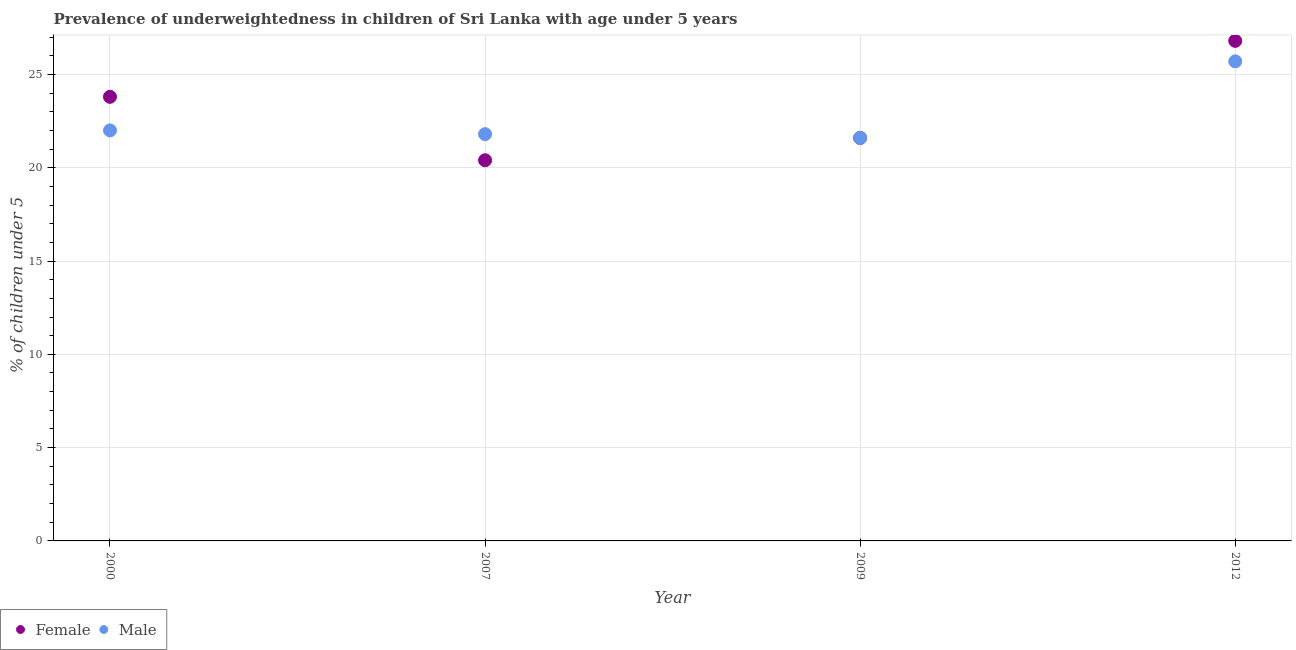Is the number of dotlines equal to the number of legend labels?
Make the answer very short. Yes. What is the percentage of underweighted female children in 2009?
Provide a succinct answer. 21.6. Across all years, what is the maximum percentage of underweighted female children?
Give a very brief answer. 26.8. Across all years, what is the minimum percentage of underweighted male children?
Keep it short and to the point. 21.6. In which year was the percentage of underweighted female children maximum?
Offer a terse response. 2012. In which year was the percentage of underweighted male children minimum?
Provide a short and direct response. 2009. What is the total percentage of underweighted male children in the graph?
Your answer should be very brief. 91.1. What is the difference between the percentage of underweighted male children in 2000 and that in 2009?
Ensure brevity in your answer.  0.4. What is the difference between the percentage of underweighted female children in 2012 and the percentage of underweighted male children in 2009?
Make the answer very short. 5.2. What is the average percentage of underweighted male children per year?
Ensure brevity in your answer.  22.78. In the year 2007, what is the difference between the percentage of underweighted male children and percentage of underweighted female children?
Ensure brevity in your answer.  1.4. In how many years, is the percentage of underweighted female children greater than 16 %?
Ensure brevity in your answer.  4. What is the ratio of the percentage of underweighted female children in 2000 to that in 2012?
Offer a very short reply. 0.89. Is the percentage of underweighted male children in 2000 less than that in 2007?
Your response must be concise. No. Is the difference between the percentage of underweighted male children in 2000 and 2009 greater than the difference between the percentage of underweighted female children in 2000 and 2009?
Your answer should be very brief. No. What is the difference between the highest and the second highest percentage of underweighted male children?
Keep it short and to the point. 3.7. What is the difference between the highest and the lowest percentage of underweighted male children?
Offer a terse response. 4.1. In how many years, is the percentage of underweighted male children greater than the average percentage of underweighted male children taken over all years?
Give a very brief answer. 1. Is the sum of the percentage of underweighted male children in 2000 and 2007 greater than the maximum percentage of underweighted female children across all years?
Give a very brief answer. Yes. Does the percentage of underweighted female children monotonically increase over the years?
Give a very brief answer. No. Is the percentage of underweighted female children strictly less than the percentage of underweighted male children over the years?
Offer a very short reply. No. How many dotlines are there?
Offer a very short reply. 2. How many years are there in the graph?
Provide a short and direct response. 4. What is the difference between two consecutive major ticks on the Y-axis?
Your response must be concise. 5. Are the values on the major ticks of Y-axis written in scientific E-notation?
Provide a succinct answer. No. Does the graph contain grids?
Offer a terse response. Yes. How many legend labels are there?
Provide a short and direct response. 2. How are the legend labels stacked?
Ensure brevity in your answer.  Horizontal. What is the title of the graph?
Keep it short and to the point. Prevalence of underweightedness in children of Sri Lanka with age under 5 years. What is the label or title of the X-axis?
Your answer should be very brief. Year. What is the label or title of the Y-axis?
Your answer should be compact.  % of children under 5. What is the  % of children under 5 in Female in 2000?
Provide a short and direct response. 23.8. What is the  % of children under 5 in Male in 2000?
Provide a succinct answer. 22. What is the  % of children under 5 of Female in 2007?
Keep it short and to the point. 20.4. What is the  % of children under 5 in Male in 2007?
Provide a short and direct response. 21.8. What is the  % of children under 5 of Female in 2009?
Your answer should be compact. 21.6. What is the  % of children under 5 in Male in 2009?
Offer a terse response. 21.6. What is the  % of children under 5 of Female in 2012?
Offer a terse response. 26.8. What is the  % of children under 5 in Male in 2012?
Ensure brevity in your answer.  25.7. Across all years, what is the maximum  % of children under 5 of Female?
Offer a terse response. 26.8. Across all years, what is the maximum  % of children under 5 in Male?
Make the answer very short. 25.7. Across all years, what is the minimum  % of children under 5 of Female?
Provide a succinct answer. 20.4. Across all years, what is the minimum  % of children under 5 of Male?
Provide a succinct answer. 21.6. What is the total  % of children under 5 in Female in the graph?
Provide a succinct answer. 92.6. What is the total  % of children under 5 in Male in the graph?
Your answer should be compact. 91.1. What is the difference between the  % of children under 5 in Female in 2000 and that in 2007?
Provide a succinct answer. 3.4. What is the difference between the  % of children under 5 in Male in 2000 and that in 2009?
Offer a very short reply. 0.4. What is the difference between the  % of children under 5 of Female in 2000 and that in 2012?
Give a very brief answer. -3. What is the difference between the  % of children under 5 of Male in 2000 and that in 2012?
Keep it short and to the point. -3.7. What is the difference between the  % of children under 5 in Female in 2007 and that in 2009?
Make the answer very short. -1.2. What is the difference between the  % of children under 5 of Male in 2007 and that in 2009?
Your answer should be very brief. 0.2. What is the difference between the  % of children under 5 in Female in 2007 and that in 2012?
Provide a succinct answer. -6.4. What is the difference between the  % of children under 5 of Male in 2007 and that in 2012?
Make the answer very short. -3.9. What is the difference between the  % of children under 5 in Female in 2009 and that in 2012?
Make the answer very short. -5.2. What is the difference between the  % of children under 5 of Male in 2009 and that in 2012?
Offer a very short reply. -4.1. What is the difference between the  % of children under 5 of Female in 2000 and the  % of children under 5 of Male in 2009?
Your response must be concise. 2.2. What is the average  % of children under 5 in Female per year?
Provide a short and direct response. 23.15. What is the average  % of children under 5 of Male per year?
Your answer should be compact. 22.77. In the year 2000, what is the difference between the  % of children under 5 in Female and  % of children under 5 in Male?
Keep it short and to the point. 1.8. In the year 2007, what is the difference between the  % of children under 5 of Female and  % of children under 5 of Male?
Make the answer very short. -1.4. In the year 2009, what is the difference between the  % of children under 5 of Female and  % of children under 5 of Male?
Offer a very short reply. 0. In the year 2012, what is the difference between the  % of children under 5 in Female and  % of children under 5 in Male?
Provide a succinct answer. 1.1. What is the ratio of the  % of children under 5 in Male in 2000 to that in 2007?
Provide a succinct answer. 1.01. What is the ratio of the  % of children under 5 in Female in 2000 to that in 2009?
Keep it short and to the point. 1.1. What is the ratio of the  % of children under 5 of Male in 2000 to that in 2009?
Offer a very short reply. 1.02. What is the ratio of the  % of children under 5 of Female in 2000 to that in 2012?
Your response must be concise. 0.89. What is the ratio of the  % of children under 5 in Male in 2000 to that in 2012?
Your answer should be very brief. 0.86. What is the ratio of the  % of children under 5 of Female in 2007 to that in 2009?
Ensure brevity in your answer.  0.94. What is the ratio of the  % of children under 5 of Male in 2007 to that in 2009?
Offer a very short reply. 1.01. What is the ratio of the  % of children under 5 in Female in 2007 to that in 2012?
Your answer should be very brief. 0.76. What is the ratio of the  % of children under 5 in Male in 2007 to that in 2012?
Your answer should be compact. 0.85. What is the ratio of the  % of children under 5 of Female in 2009 to that in 2012?
Provide a short and direct response. 0.81. What is the ratio of the  % of children under 5 of Male in 2009 to that in 2012?
Ensure brevity in your answer.  0.84. What is the difference between the highest and the second highest  % of children under 5 in Female?
Ensure brevity in your answer.  3. 